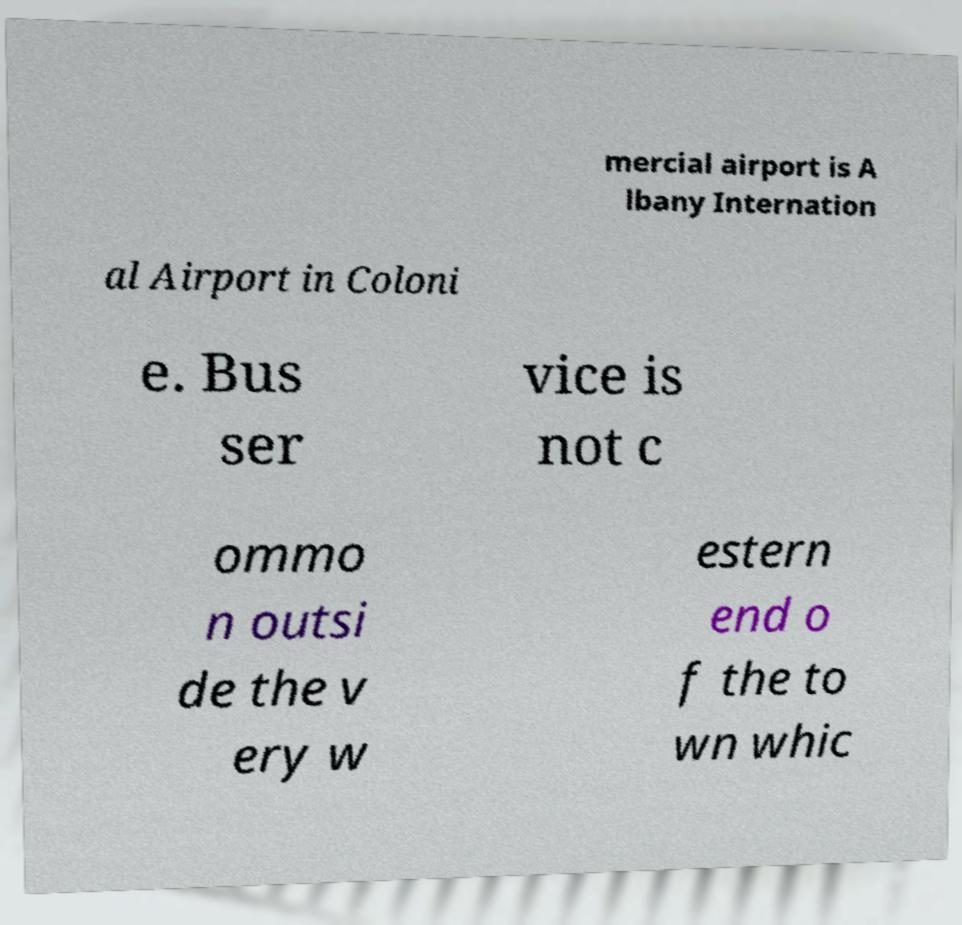Please read and relay the text visible in this image. What does it say? mercial airport is A lbany Internation al Airport in Coloni e. Bus ser vice is not c ommo n outsi de the v ery w estern end o f the to wn whic 